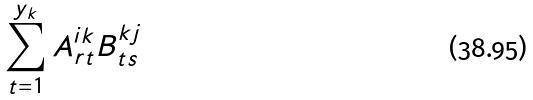Convert formula to latex. <formula><loc_0><loc_0><loc_500><loc_500>\sum _ { t = 1 } ^ { y _ { k } } A _ { r t } ^ { i k } B _ { t s } ^ { k j }</formula> 